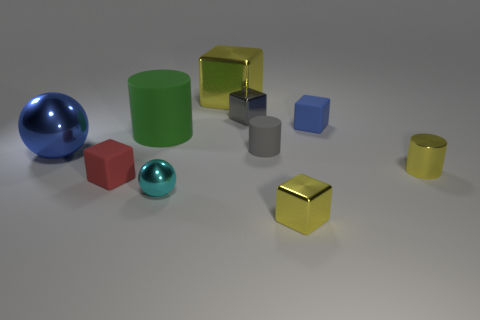What size is the other cyan sphere that is the same material as the big ball?
Ensure brevity in your answer.  Small. There is a blue object that is right of the big yellow metal thing; what is its shape?
Provide a succinct answer. Cube. What size is the blue metallic object that is the same shape as the cyan shiny thing?
Your response must be concise. Large. What number of big yellow things are behind the yellow metallic thing that is behind the tiny gray metallic thing behind the tiny blue matte cube?
Provide a short and direct response. 0. Are there an equal number of tiny gray cubes left of the tiny gray shiny thing and red matte spheres?
Offer a very short reply. Yes. What number of cubes are either tiny yellow objects or green objects?
Ensure brevity in your answer.  1. Do the tiny metal cylinder and the big metallic block have the same color?
Make the answer very short. Yes. Are there an equal number of large matte cylinders that are right of the large yellow metal block and small cyan spheres that are right of the tiny rubber cylinder?
Make the answer very short. Yes. What color is the large metallic cube?
Provide a short and direct response. Yellow. How many things are tiny metallic objects that are behind the tiny cyan metallic thing or yellow metallic cubes?
Provide a short and direct response. 4. 